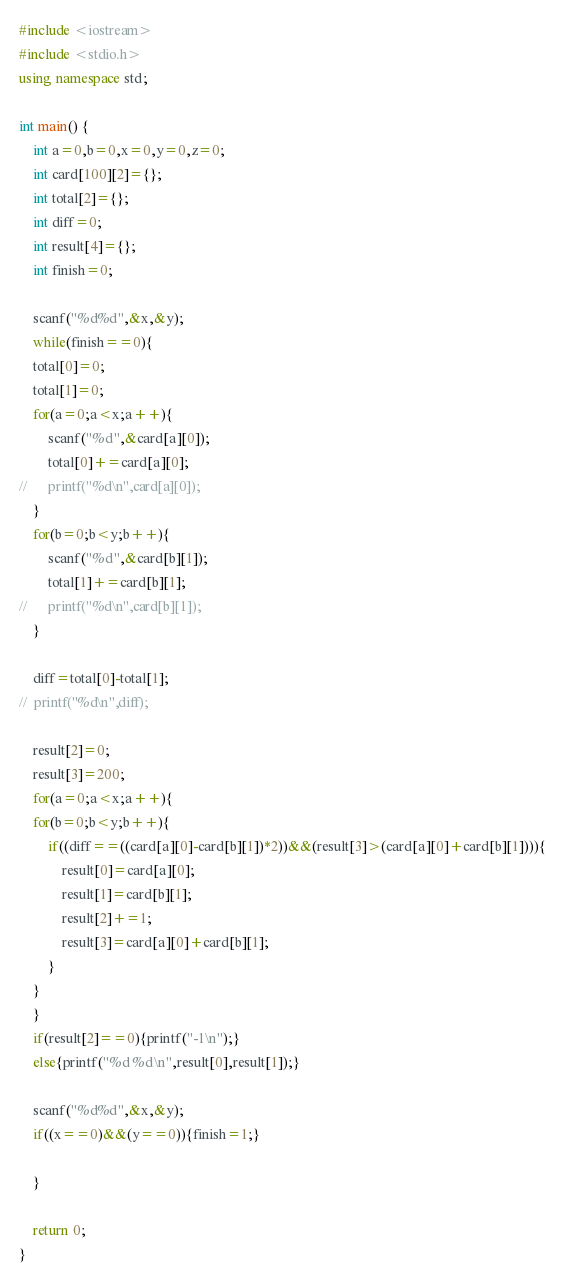Convert code to text. <code><loc_0><loc_0><loc_500><loc_500><_C++_>#include <iostream>
#include <stdio.h>
using namespace std;

int main() {
   	int a=0,b=0,x=0,y=0,z=0;
	int card[100][2]={};
	int total[2]={};
   	int diff=0;
	int result[4]={};
   	int finish=0;

	scanf("%d%d",&x,&y);
	while(finish==0){
	total[0]=0;
	total[1]=0;
	for(a=0;a<x;a++){
		scanf("%d",&card[a][0]);
		total[0]+=card[a][0];
//		printf("%d\n",card[a][0]);
	}
	for(b=0;b<y;b++){
		scanf("%d",&card[b][1]);
		total[1]+=card[b][1];
//		printf("%d\n",card[b][1]);
	}
	
	diff=total[0]-total[1];
//	printf("%d\n",diff);

	result[2]=0;
	result[3]=200;
	for(a=0;a<x;a++){
	for(b=0;b<y;b++){
		if((diff==((card[a][0]-card[b][1])*2))&&(result[3]>(card[a][0]+card[b][1]))){
			result[0]=card[a][0];
			result[1]=card[b][1];
			result[2]+=1;
			result[3]=card[a][0]+card[b][1];
		}	
	}
	}
	if(result[2]==0){printf("-1\n");}
	else{printf("%d %d\n",result[0],result[1]);}
	
	scanf("%d%d",&x,&y);
	if((x==0)&&(y==0)){finish=1;}

	}
	
	return 0;
}</code> 